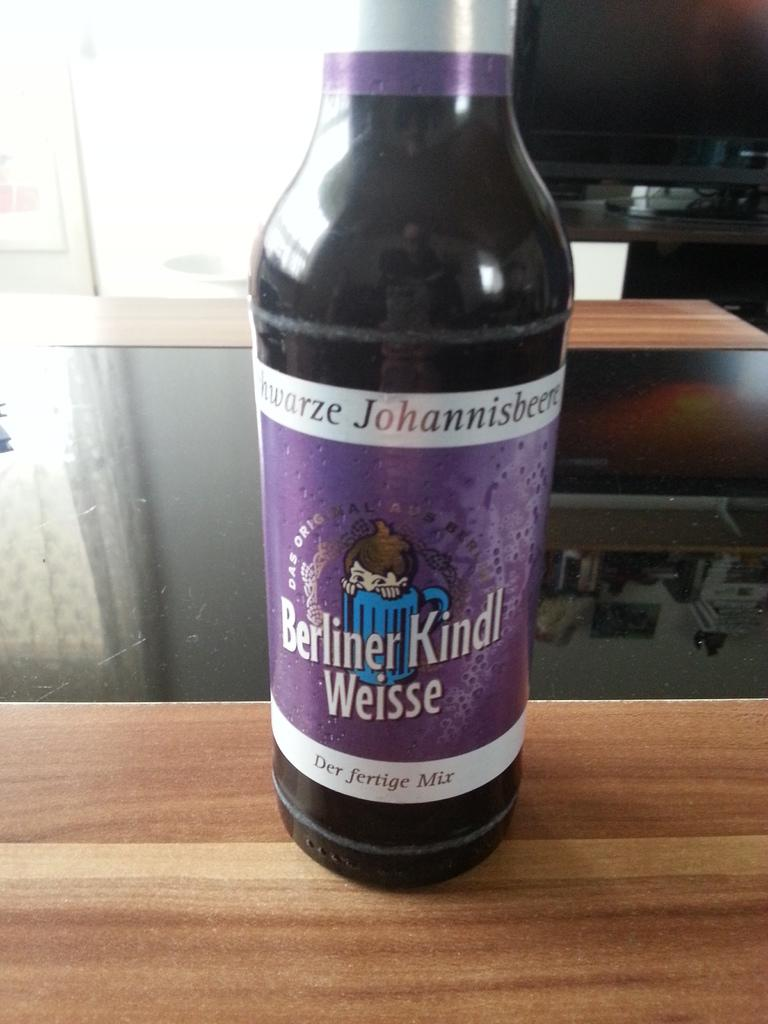<image>
Provide a brief description of the given image. A bottle with a purple label from Berliner Kindl Weisse. 